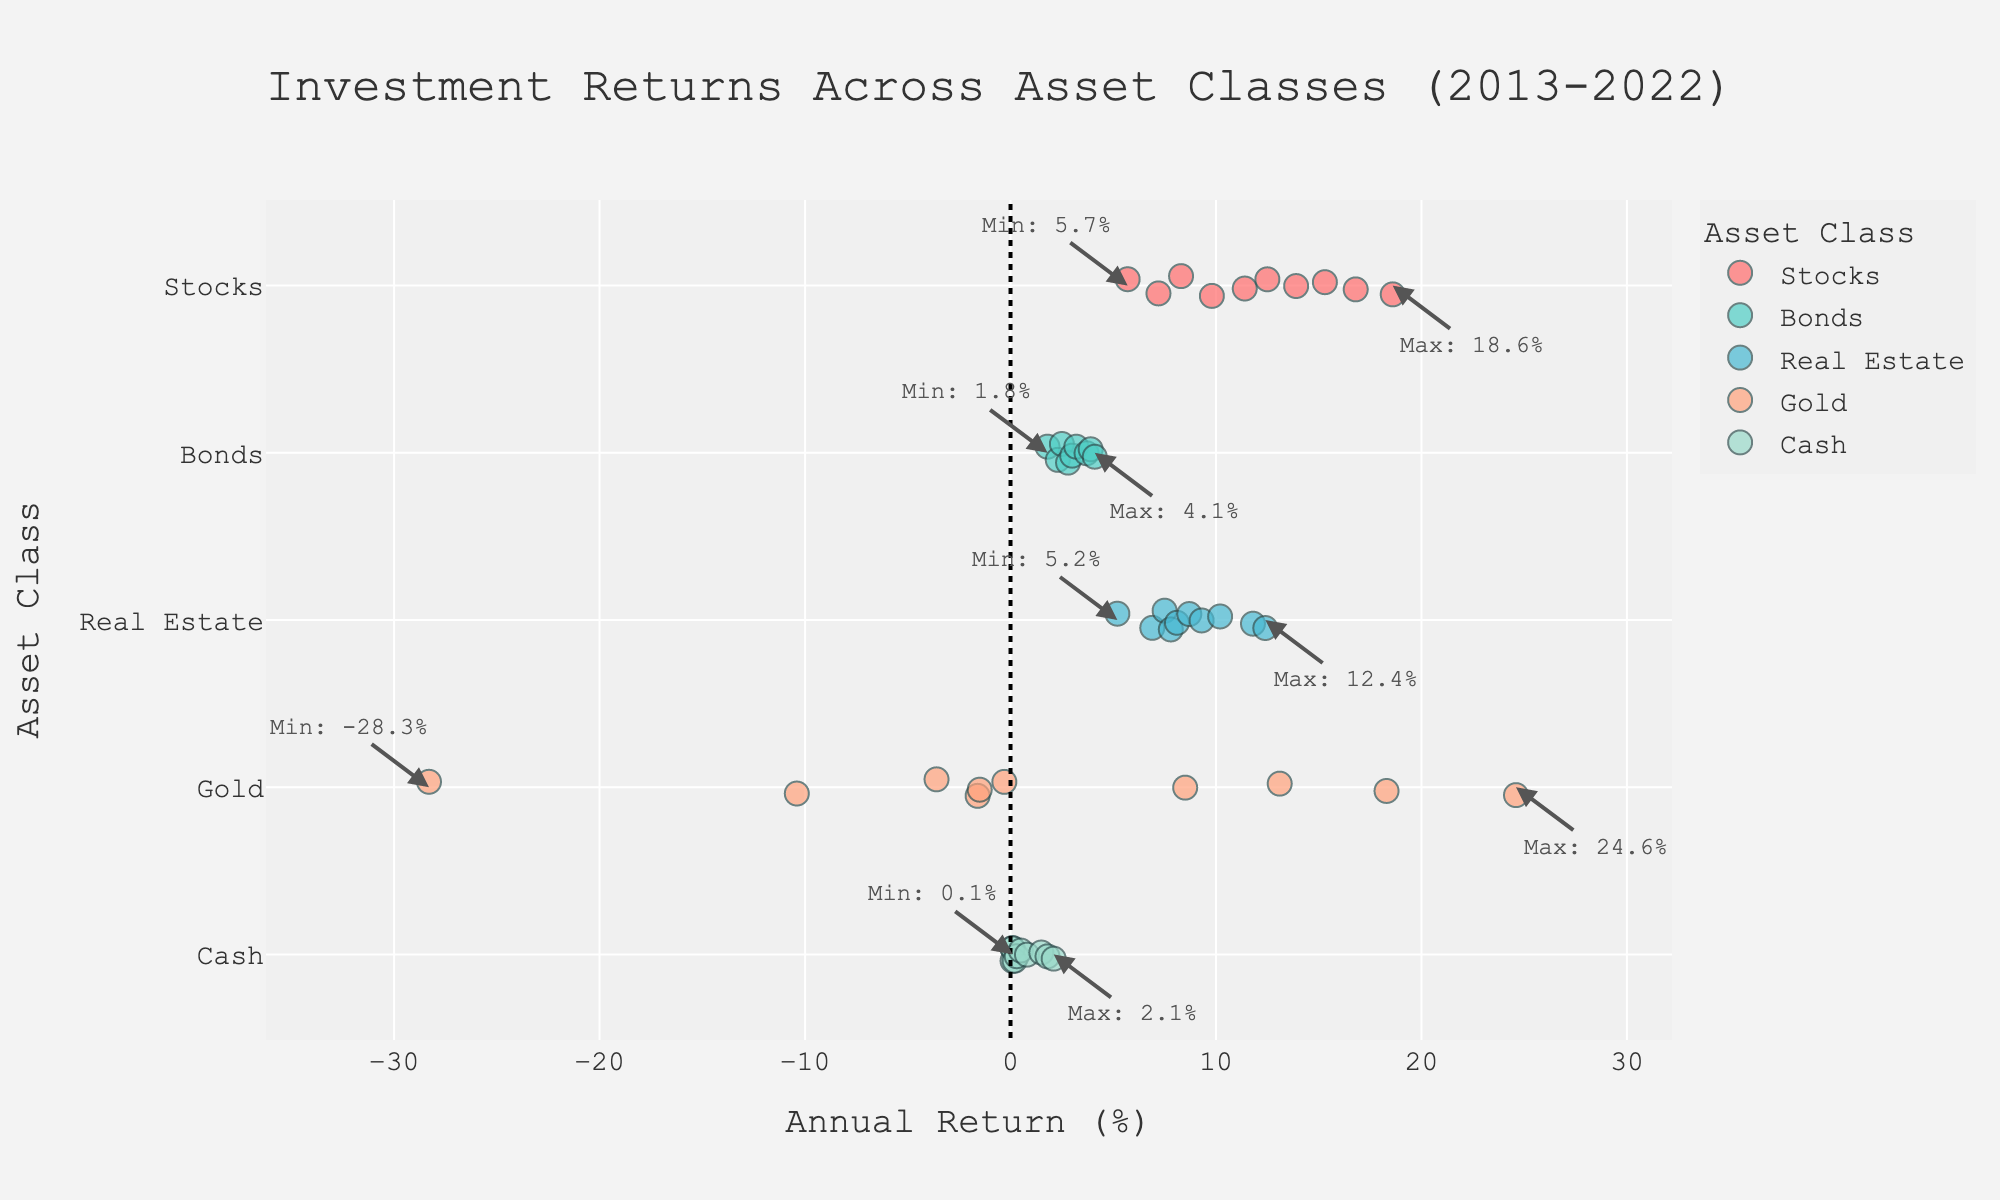What is the title of the plot? The title of the plot is located at the top center and describes the main theme of the figure.
Answer: Investment Returns Across Asset Classes (2013-2022) Which asset class had the highest max return and what was the value? By looking at the annotated max values on the right of each strip, we see the highest max return is for Gold.
Answer: 24.6% How many asset classes are represented in the plot? The y-axis lists the different asset classes, and we can count them.
Answer: 5 What is the minimum return for the Real Estate asset class and in which year did it occur? Locate the annotation for the minimum value on the Real Estate strip to find the year and value.
Answer: 5.2% in 2020 Which asset class had the most negative return and what was the value? Negative returns fall to the left of the zero line, and we see the lowest value belongs to Gold.
Answer: -28.3% Which asset class had relatively stable returns with least deviation over the years? Compare the spread of data points across asset classes to see which class has the tightest grouping.
Answer: Cash What years did Stocks have returns below 10%? Look along the Stocks strip for points that are below the 10% mark and read off the years from the hover data.
Answer: 2014, 2016, 2018, 2020, 2022 For which asset class do annotations for both the min and max returns point to the same year? Compare the annotations for min and max values across different asset classes to see which have arrows pointing to the same year.
Answer: None What is the range of annual returns for the Bonds asset class? Find the difference between the maximum and minimum values annotated on the Bonds strip.
Answer: 2.1% Which asset class shows the most fluctuation in returns based on the visual spread of data points? Observe the spread of points for each asset class and identify the one with the widest spread.
Answer: Gold 